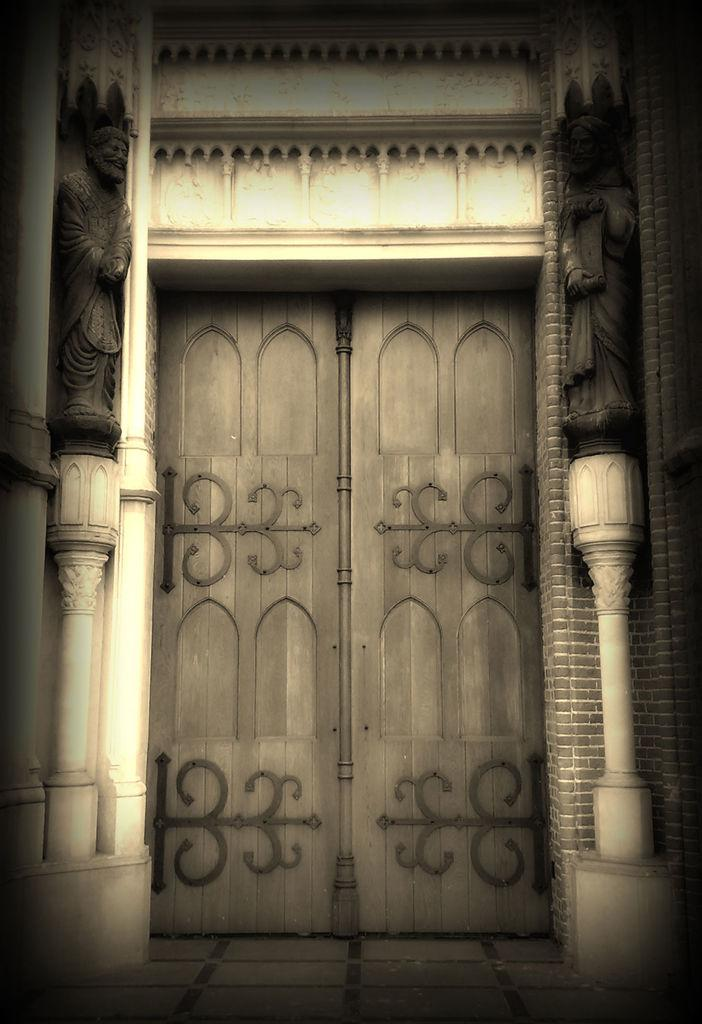What type of art is depicted in the image? There are sculptures of persons in the image. What other elements can be seen in the image besides the sculptures? There are trees in the image. What type of glue is used to attach the throat to the sculpture in the image? There is no mention of a throat or glue in the image; it features sculptures of persons and trees. 